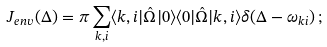<formula> <loc_0><loc_0><loc_500><loc_500>J _ { e n v } ( \Delta ) = { \pi } \sum _ { { k } , i } \langle { k } , i | \hat { \Omega } | 0 \rangle \langle 0 | \hat { \Omega } | { k } , i \rangle \delta ( \Delta - { } { \omega } _ { { k } i } ) \, ;</formula> 